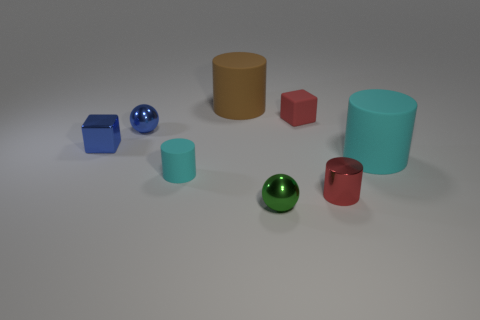Add 1 tiny brown metal things. How many objects exist? 9 Subtract all blocks. How many objects are left? 6 Subtract all tiny red shiny things. Subtract all cyan cylinders. How many objects are left? 5 Add 2 rubber cylinders. How many rubber cylinders are left? 5 Add 2 purple metal cubes. How many purple metal cubes exist? 2 Subtract 0 purple balls. How many objects are left? 8 